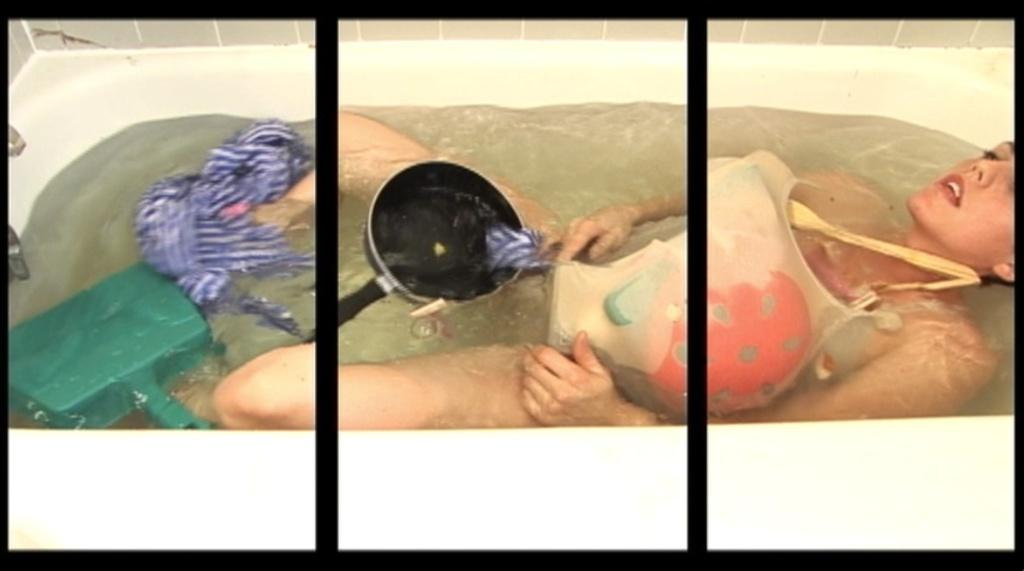What is the person in the image doing? The person is in the bathtub. What else can be seen in the bathtub besides the person? There is a cloth, a pan, and an unspecified object in the bathtub. What is visible in the background of the image? There is a wall in the background of the image. What type of bulb is hanging from the ceiling in the image? There is no bulb visible in the image; it only shows a person in the bathtub and other objects in the bathtub. How many family members are present in the image? The image only shows a person in the bathtub, so it is not possible to determine the number of family members present. 